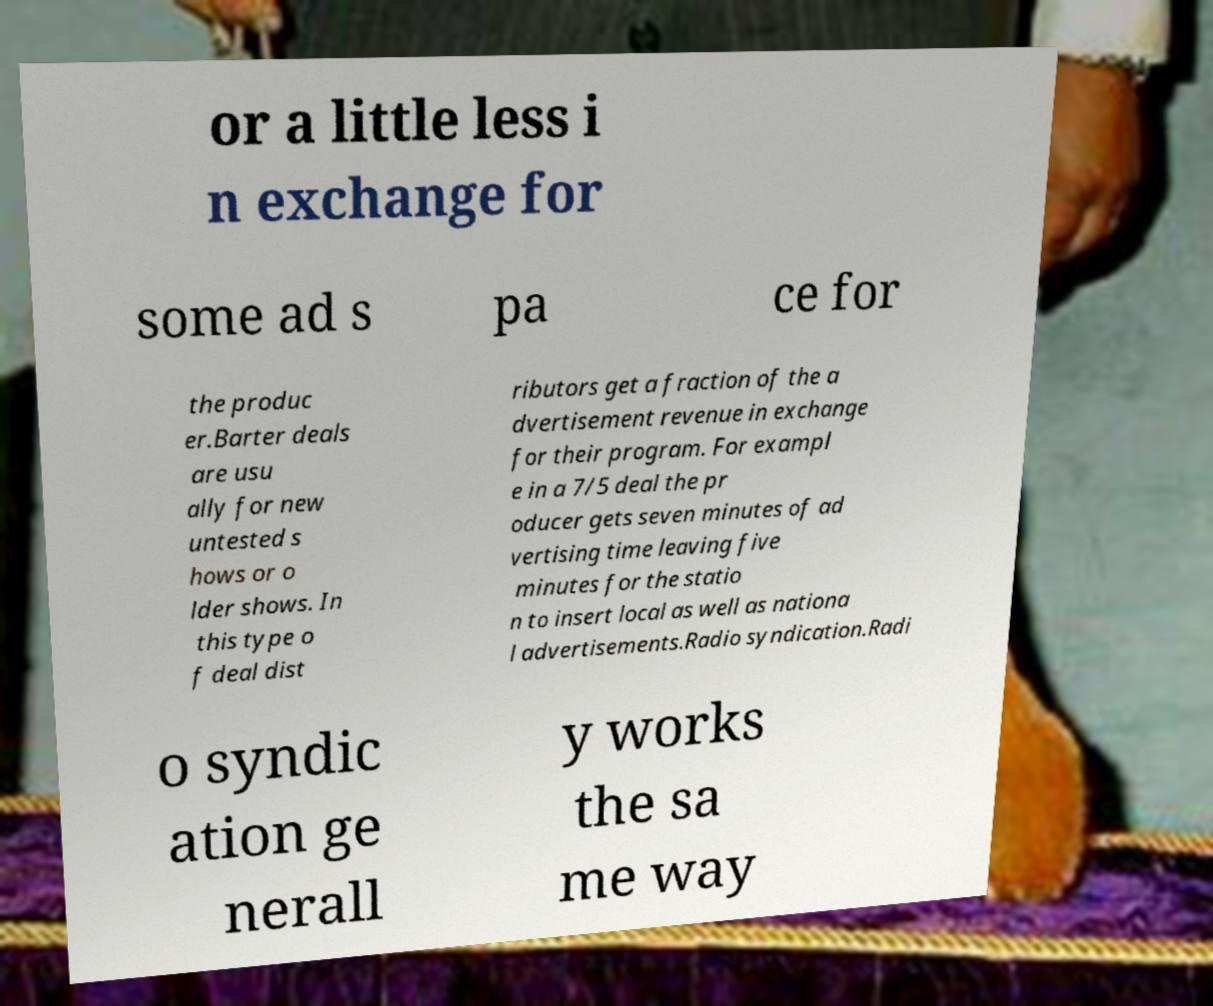Please read and relay the text visible in this image. What does it say? or a little less i n exchange for some ad s pa ce for the produc er.Barter deals are usu ally for new untested s hows or o lder shows. In this type o f deal dist ributors get a fraction of the a dvertisement revenue in exchange for their program. For exampl e in a 7/5 deal the pr oducer gets seven minutes of ad vertising time leaving five minutes for the statio n to insert local as well as nationa l advertisements.Radio syndication.Radi o syndic ation ge nerall y works the sa me way 